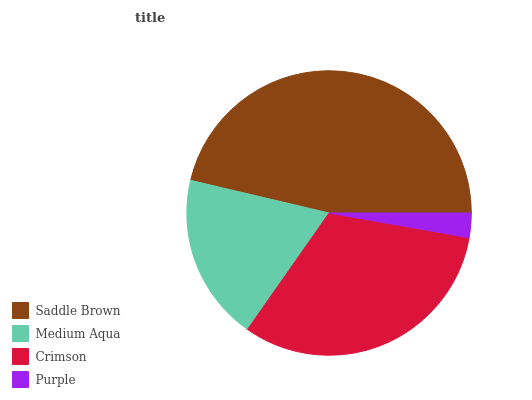Is Purple the minimum?
Answer yes or no. Yes. Is Saddle Brown the maximum?
Answer yes or no. Yes. Is Medium Aqua the minimum?
Answer yes or no. No. Is Medium Aqua the maximum?
Answer yes or no. No. Is Saddle Brown greater than Medium Aqua?
Answer yes or no. Yes. Is Medium Aqua less than Saddle Brown?
Answer yes or no. Yes. Is Medium Aqua greater than Saddle Brown?
Answer yes or no. No. Is Saddle Brown less than Medium Aqua?
Answer yes or no. No. Is Crimson the high median?
Answer yes or no. Yes. Is Medium Aqua the low median?
Answer yes or no. Yes. Is Saddle Brown the high median?
Answer yes or no. No. Is Purple the low median?
Answer yes or no. No. 